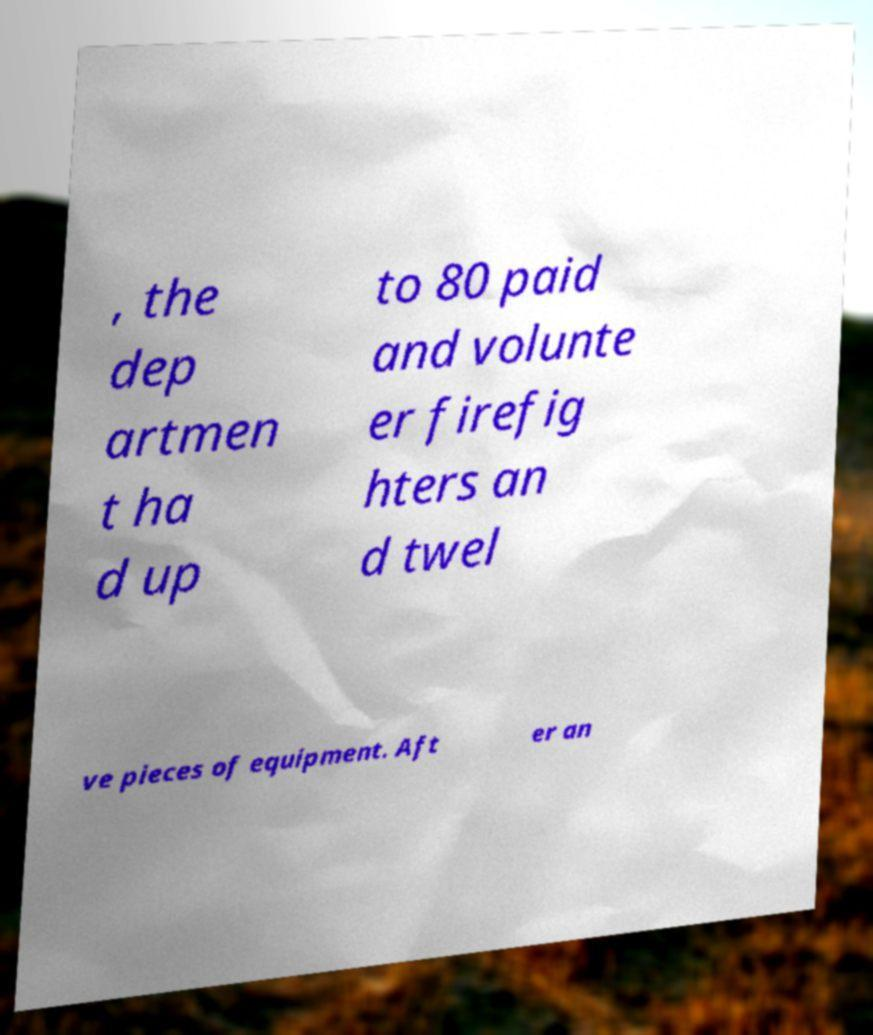Can you accurately transcribe the text from the provided image for me? , the dep artmen t ha d up to 80 paid and volunte er firefig hters an d twel ve pieces of equipment. Aft er an 